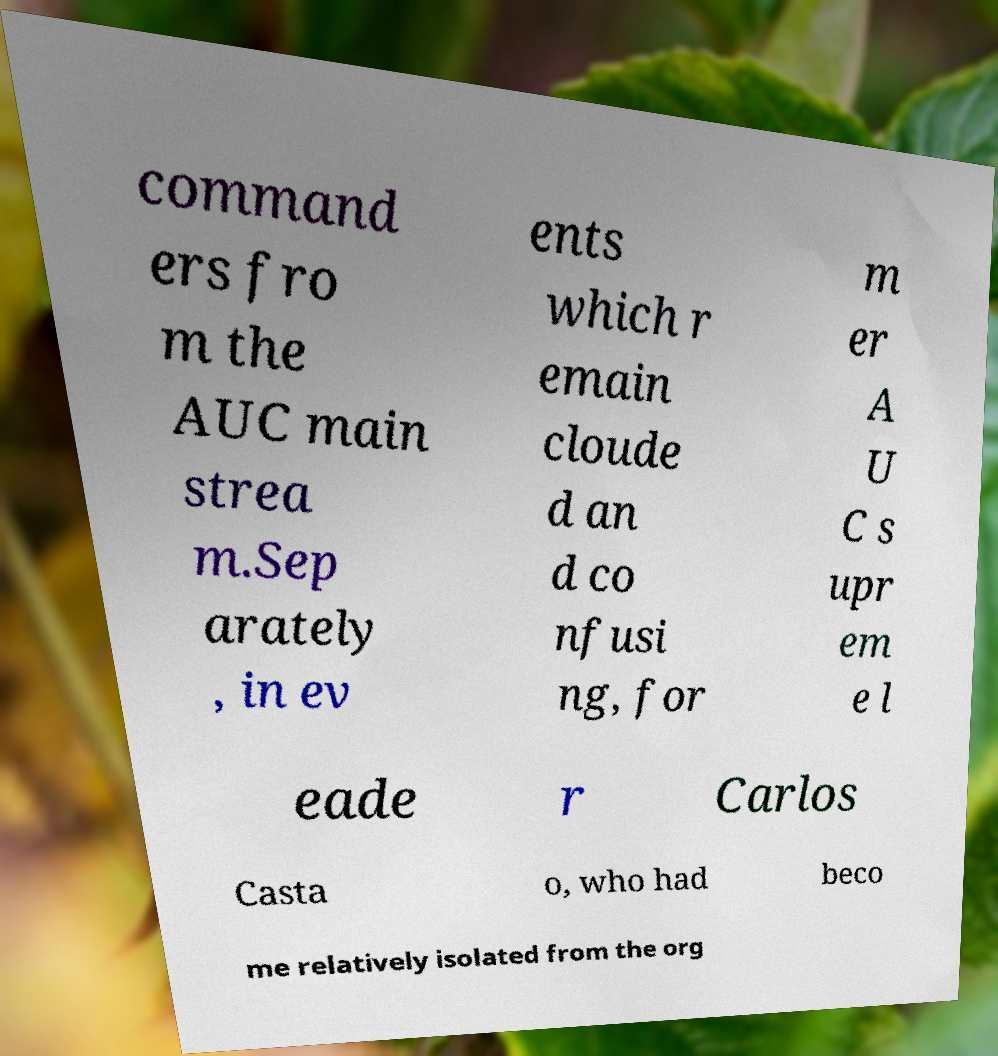Can you accurately transcribe the text from the provided image for me? command ers fro m the AUC main strea m.Sep arately , in ev ents which r emain cloude d an d co nfusi ng, for m er A U C s upr em e l eade r Carlos Casta o, who had beco me relatively isolated from the org 